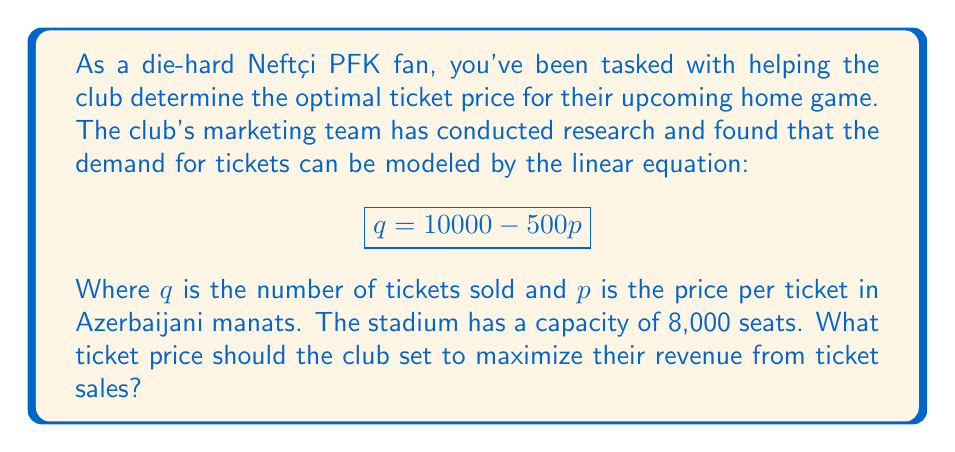Could you help me with this problem? Let's approach this step-by-step:

1) The revenue $R$ is the product of the price per ticket $p$ and the quantity of tickets sold $q$:

   $$ R = pq $$

2) We can substitute the demand equation into this formula:

   $$ R = p(10000 - 500p) $$

3) Expand this equation:

   $$ R = 10000p - 500p^2 $$

4) To find the maximum revenue, we need to find the vertex of this parabola. We can do this by finding where the derivative of $R$ with respect to $p$ equals zero:

   $$ \frac{dR}{dp} = 10000 - 1000p $$

5) Set this equal to zero and solve for $p$:

   $$ 10000 - 1000p = 0 $$
   $$ 1000p = 10000 $$
   $$ p = 10 $$

6) This gives us the price that maximizes revenue. However, we need to check if this results in a number of tickets sold that exceeds the stadium capacity:

   $$ q = 10000 - 500(10) = 5000 $$

7) Since 5000 is less than the stadium capacity of 8000, this price is feasible.

8) We can verify this is a maximum (not a minimum) by checking the second derivative:

   $$ \frac{d^2R}{dp^2} = -1000 $$

   This is negative, confirming we have found a maximum.
Answer: The optimal ticket price to maximize revenue is 10 Azerbaijani manats per ticket. 